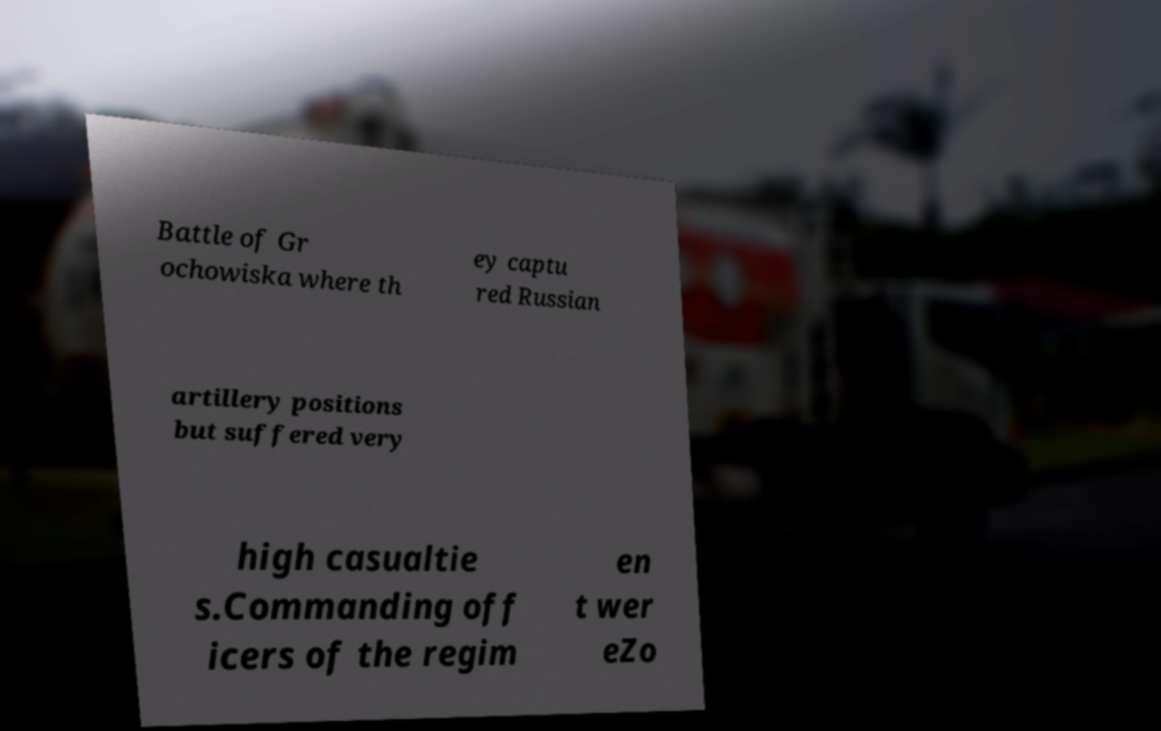What messages or text are displayed in this image? I need them in a readable, typed format. Battle of Gr ochowiska where th ey captu red Russian artillery positions but suffered very high casualtie s.Commanding off icers of the regim en t wer eZo 